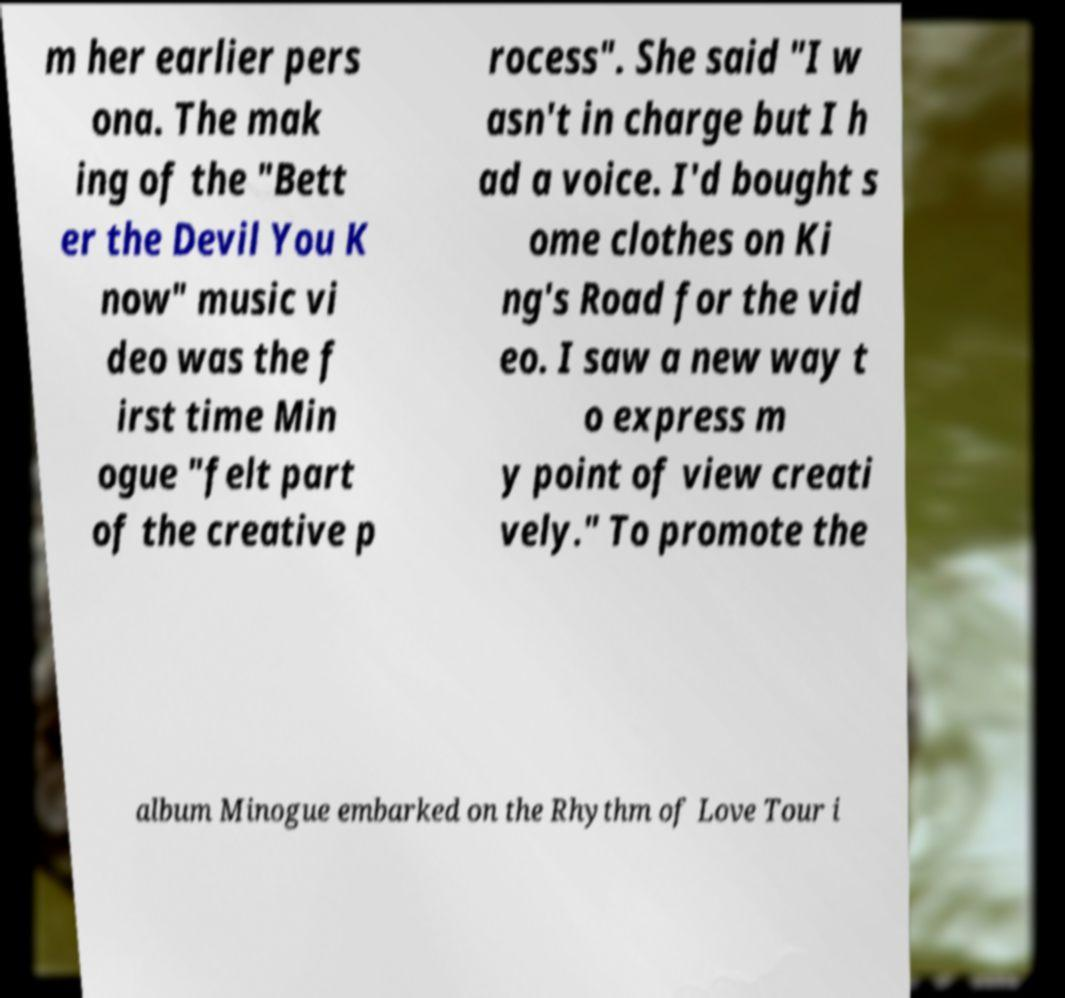For documentation purposes, I need the text within this image transcribed. Could you provide that? m her earlier pers ona. The mak ing of the "Bett er the Devil You K now" music vi deo was the f irst time Min ogue "felt part of the creative p rocess". She said "I w asn't in charge but I h ad a voice. I'd bought s ome clothes on Ki ng's Road for the vid eo. I saw a new way t o express m y point of view creati vely." To promote the album Minogue embarked on the Rhythm of Love Tour i 